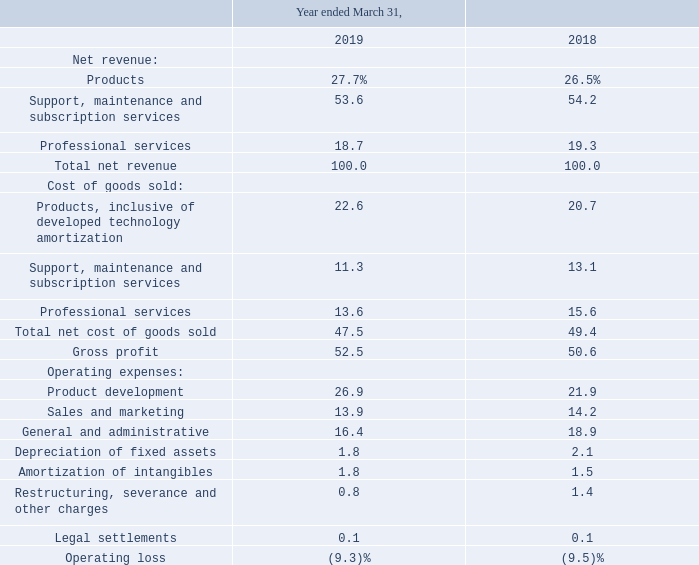The following table presents the percentage relationship of our Consolidated Statement of Operations line items to our consolidated net revenues for the periods presented:
Net revenue. Total revenue increased $13.5 million, or 10.6%, in fiscal 2019 compared to fiscal 2018. Products revenue increased $5.3 million, or 15.7%, due to growth in third-party hardware sales and in on premise software sales, which grew more than 20% compared to the prior year.
Support, maintenance and subscription services revenue increased $6.4 million, or 9.3%, driven by growth in customers using our on premise software products that require the payment of support and maintenance along with continued increases in subscription based revenue, which increased 23.5% in fiscal 2019 compared to fiscal 2018.
Subscription based revenue comprised 17.7% of total consolidated revenues in 2019 compared to 15.8% in 2018. Professional services revenue increased $1.8 million, or 7.1%, as a result of growth in our customer base including installations of our traditional on premise and subscription based software solutions and increased responses to customer service requests.
Gross profit and gross profit margin. Our total gross profit increased $9.5 million, or 14.7%, in fiscal 2019 and total gross profit margin increased from 50.6% to 52.5%. Products gross profit decreased $0.1 million and gross profit margin decreased 3.3% to 18.4% primarily as a result of increased developed technology amortization.
Support, maintenance and subscription services gross profit increased $7.2 million and gross profit margin increased 310 basis points to 78.9% due to the scalable nature of our infrastructure supporting and hosting customers. Professional services gross profit increased $2.4 million and gross profit margin increased 7.7% to 26.9% due to increased revenue with lower costs from the restructuring of our professional services workforce during the first quarter of 2018 into a more efficient operating structure with limited use of contract labor.
Operating expenses Operating expenses, excluding the charges for legal settlements and restructuring, severance and other charges, increased $10.5 million, or 13.7%, in fiscal 2019 compared with fiscal 2018. As a percent of total revenue, operating expenses have increased 2.3% in fiscal 2019 compared with fiscal 2018.
Product development. Product development includes all expenses associated with research and development. Product development increased $9.9 million, or 35.4%, during fiscal 2019 as compared to fiscal 2018 primarily due to the reduction of cost capitalization. The products in our rGuest platform for which we had capitalized costs reached general availability by the beginning of the second quarter of fiscal 2019.
These products join our well established products with the application of agile development practices in a more dynamic development process that involves higher frequency releases of product features and functions. We capitalized $2.0 million of external use software development costs, and $0.3 million of internal use software development costs during fiscal 2019, with the full balance capitalized in Q1 fiscal 2019.
We capitalized approximately $8.9 million in total development costs during fiscal 2018. Total product development costs, including operating expenses and capitalized amounts, were $40.1 million during fiscal 2019 compared to $38.4 million in fiscal 2018. The $1.7 million increase is mostly due to continued expansion of our R&D teams and increased compensation expense as a result of bonus earnings.
Sales and marketing. Sales and marketing increased $1.6 million, or 8.7%, in fiscal 2019 compared with fiscal 2018. The change is due primarily to an increase of $1.6 million in incentive compensation related to an increase in sales, revenue and profitability during fiscal 2019.
General and administrative. General and administrative decreased $0.9 million, or 3.8%, in fiscal 2019 compared to fiscal 2018. The change is due primarily to reduced outside professional costs for legal and accounting services.
Depreciation of fixed assets. Depreciation of fixed assets decreased $0.1 million or 5% in fiscal 2019 as compared to fiscal 2018.
Amortization of intangibles. Amortization of intangibles increased $0.7 million, or 36.6%, in fiscal 2019 as compared to fiscal 2018 due to our remaining Guest suite of products being placed into service on June 30, 2018.
Restructuring, severance and other charges. Restructuring, severance, and other charges decreased $1.8 million due to non-recurring 2018 restructuring activities while charges for non-restructuring severance increased $1.2 million, resulting in a net decrease of $0.6 million during fiscal 2019. Our restructuring actions are discussed further in Note 4, Restructuring Charges.
Legal settlements. Legal settlements consist of settlements of employment and other business-related matters.
What was the increase in total revenue? $13.5 million, or 10.6%. What was the increase in the support, maintenance and subscription? $6.4 million, or 9.3%. What was the products expressed as a percentage of Net revenue in 2019? 27.7%. What was the increase / (decrease) in the percentage of professional services of revenue from 2018 to 2019?
Answer scale should be: percent. 18.7 - 19.3
Answer: -0.6. What was total revenue in 2018?
Answer scale should be: million. 13.5/10.6*100
Answer: 127.36. What was the percentage increase / (decrease) in the depreciation of fixed assets as a percentage of operating expenses from 2018 to 2019?
Answer scale should be: percent. 1.8 - 2.1
Answer: -0.3. 